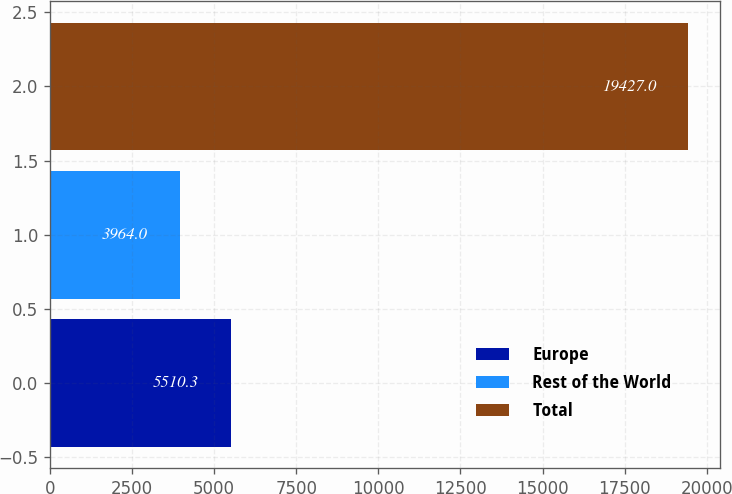Convert chart. <chart><loc_0><loc_0><loc_500><loc_500><bar_chart><fcel>Europe<fcel>Rest of the World<fcel>Total<nl><fcel>5510.3<fcel>3964<fcel>19427<nl></chart> 